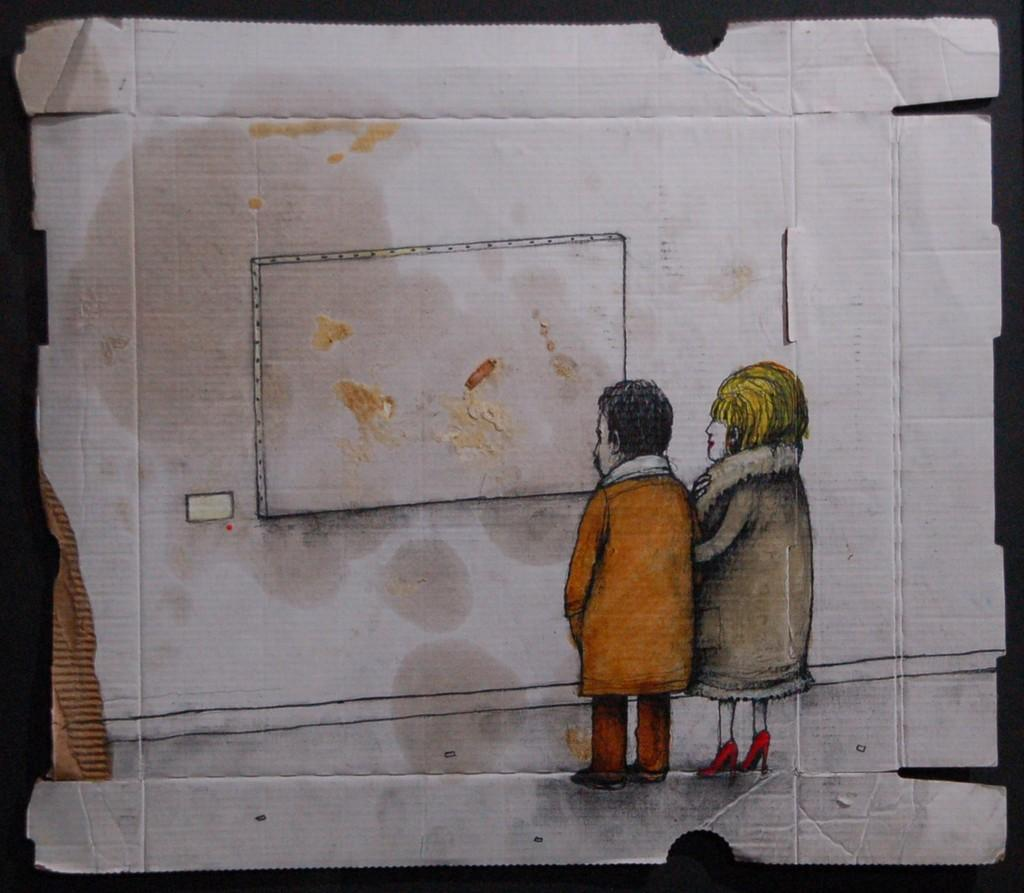What is the main object in the image? There is a cardboard in the image. What is on top of the cardboard? The cardboard has a white paper on it. What is depicted on the white paper? There is a drawing of a man and woman on the paper. What are the man and woman doing in the drawing? The drawing depicts the man and woman watching a board. What can be seen on the paper besides the drawing? There are cream particles on the paper. What time does the team meet in the image? There is no mention of a team or a meeting in the image; it features a cardboard with a drawing of a man and woman watching a board. 